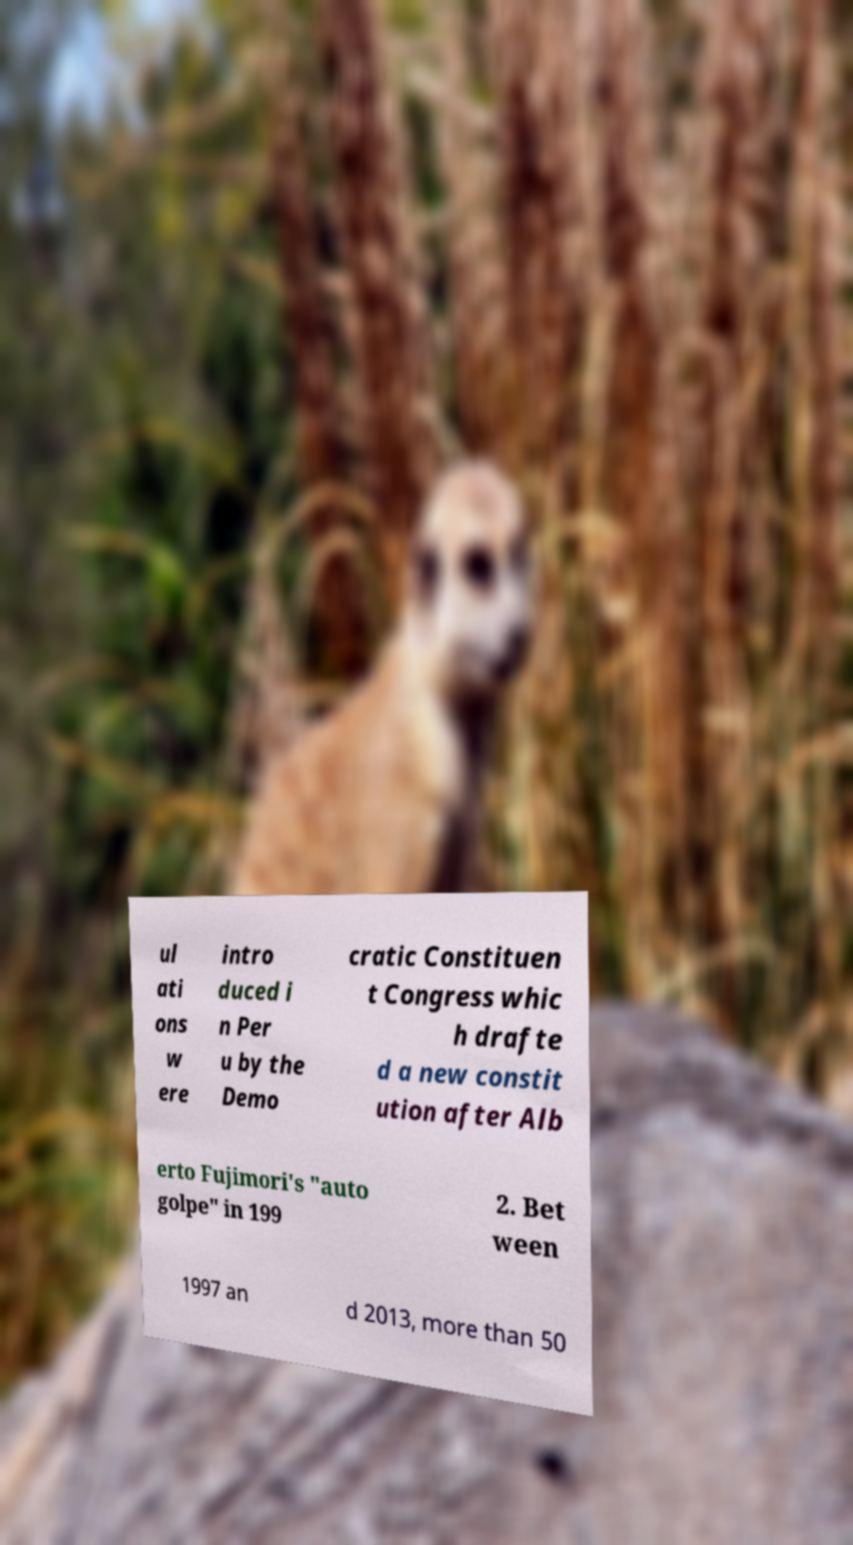Please identify and transcribe the text found in this image. ul ati ons w ere intro duced i n Per u by the Demo cratic Constituen t Congress whic h drafte d a new constit ution after Alb erto Fujimori's "auto golpe" in 199 2. Bet ween 1997 an d 2013, more than 50 